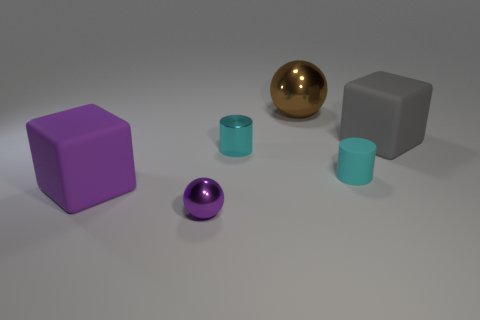Do the colors of the objects represent anything specific? The selection of colors in the image doesn't appear to point to any specific representation. They might have been chosen simply for their visual contrast and to create a pleasing aesthetic. However, the purple, teal, and gray could suggest a modern or minimalist palette often used in contemporary design. 